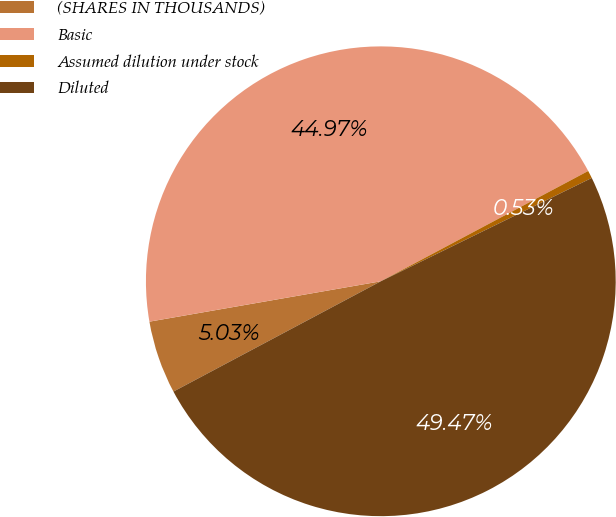Convert chart to OTSL. <chart><loc_0><loc_0><loc_500><loc_500><pie_chart><fcel>(SHARES IN THOUSANDS)<fcel>Basic<fcel>Assumed dilution under stock<fcel>Diluted<nl><fcel>5.03%<fcel>44.97%<fcel>0.53%<fcel>49.47%<nl></chart> 